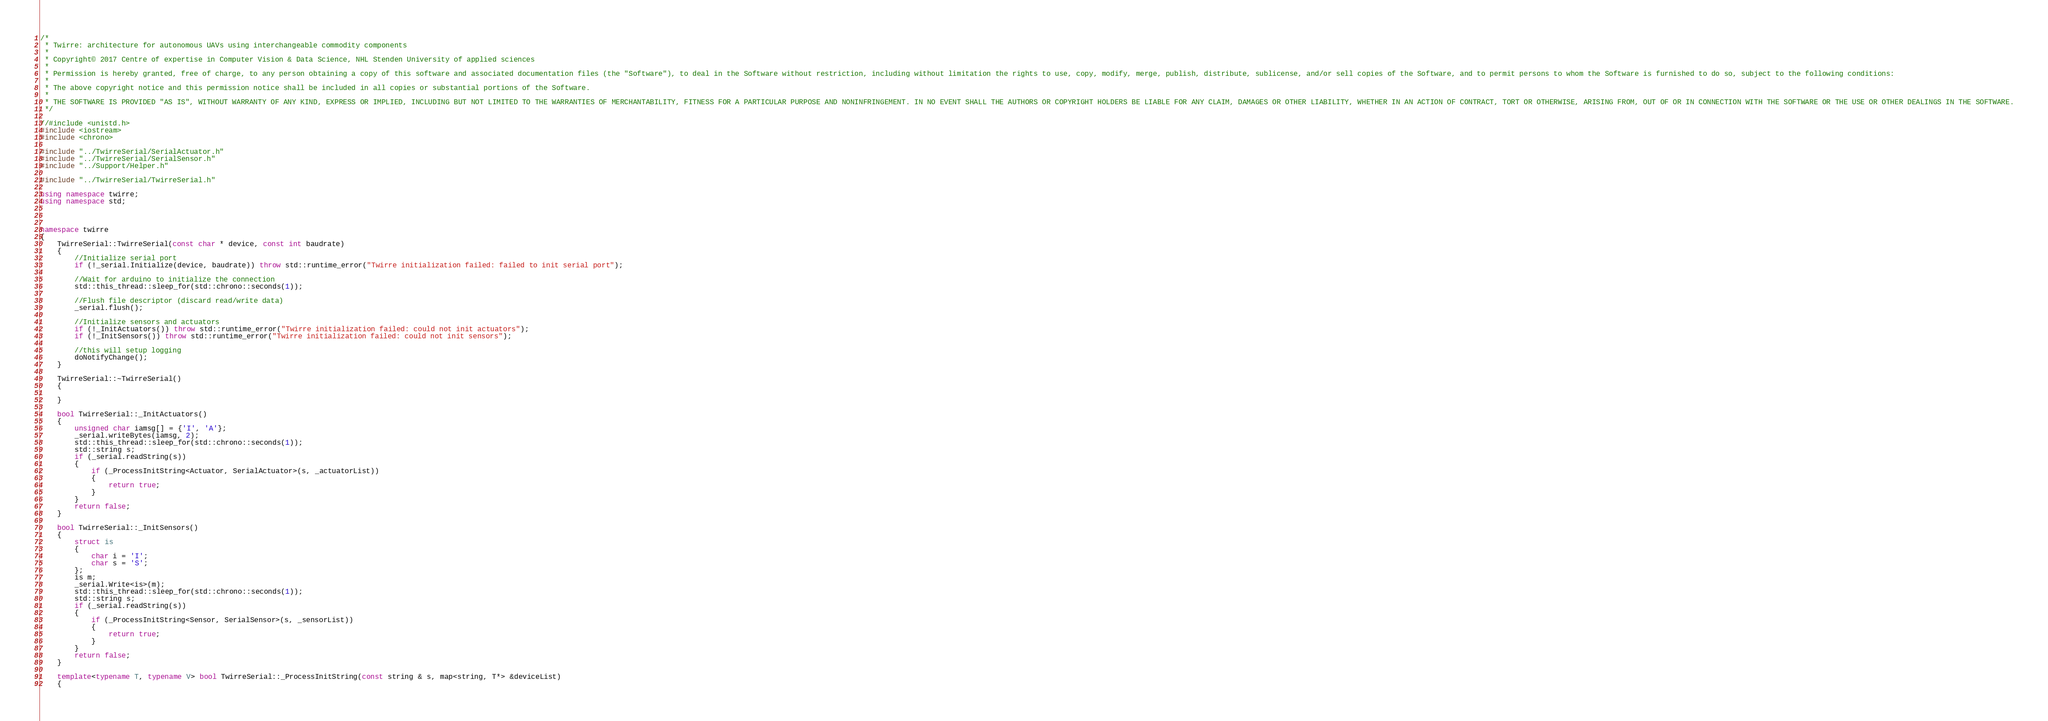Convert code to text. <code><loc_0><loc_0><loc_500><loc_500><_C++_>/*
 * Twirre: architecture for autonomous UAVs using interchangeable commodity components
 *
 * Copyright© 2017 Centre of expertise in Computer Vision & Data Science, NHL Stenden University of applied sciences
 *
 * Permission is hereby granted, free of charge, to any person obtaining a copy of this software and associated documentation files (the "Software"), to deal in the Software without restriction, including without limitation the rights to use, copy, modify, merge, publish, distribute, sublicense, and/or sell copies of the Software, and to permit persons to whom the Software is furnished to do so, subject to the following conditions:
 * 
 * The above copyright notice and this permission notice shall be included in all copies or substantial portions of the Software.
 *
 * THE SOFTWARE IS PROVIDED "AS IS", WITHOUT WARRANTY OF ANY KIND, EXPRESS OR IMPLIED, INCLUDING BUT NOT LIMITED TO THE WARRANTIES OF MERCHANTABILITY, FITNESS FOR A PARTICULAR PURPOSE AND NONINFRINGEMENT. IN NO EVENT SHALL THE AUTHORS OR COPYRIGHT HOLDERS BE LIABLE FOR ANY CLAIM, DAMAGES OR OTHER LIABILITY, WHETHER IN AN ACTION OF CONTRACT, TORT OR OTHERWISE, ARISING FROM, OUT OF OR IN CONNECTION WITH THE SOFTWARE OR THE USE OR OTHER DEALINGS IN THE SOFTWARE.
 */

//#include <unistd.h>
#include <iostream>
#include <chrono>

#include "../TwirreSerial/SerialActuator.h"
#include "../TwirreSerial/SerialSensor.h"
#include "../Support/Helper.h"

#include "../TwirreSerial/TwirreSerial.h"

using namespace twirre;
using namespace std;



namespace twirre
{
	TwirreSerial::TwirreSerial(const char * device, const int baudrate)
	{
		//Initialize serial port
		if (!_serial.Initialize(device, baudrate)) throw std::runtime_error("Twirre initialization failed: failed to init serial port");

		//Wait for arduino to initialize the connection
		std::this_thread::sleep_for(std::chrono::seconds(1));

		//Flush file descriptor (discard read/write data)
		_serial.flush();

		//Initialize sensors and actuators
		if (!_InitActuators()) throw std::runtime_error("Twirre initialization failed: could not init actuators");
		if (!_InitSensors()) throw std::runtime_error("Twirre initialization failed: could not init sensors");

		//this will setup logging
		doNotifyChange();
	}

	TwirreSerial::~TwirreSerial()
	{

	}

	bool TwirreSerial::_InitActuators()
	{
		unsigned char iamsg[] = {'I', 'A'};
		_serial.writeBytes(iamsg, 2);
		std::this_thread::sleep_for(std::chrono::seconds(1));
		std::string s;
		if (_serial.readString(s))
		{
			if (_ProcessInitString<Actuator, SerialActuator>(s, _actuatorList))
			{
				return true;
			}
		}
		return false;
	}

	bool TwirreSerial::_InitSensors()
	{
		struct is
		{
			char i = 'I';
			char s = 'S';
		};
		is m;
		_serial.Write<is>(m);
		std::this_thread::sleep_for(std::chrono::seconds(1));
		std::string s;
		if (_serial.readString(s))
		{
			if (_ProcessInitString<Sensor, SerialSensor>(s, _sensorList))
			{
				return true;
			}
		}
		return false;
	}

	template<typename T, typename V> bool TwirreSerial::_ProcessInitString(const string & s, map<string, T*> &deviceList)
	{</code> 